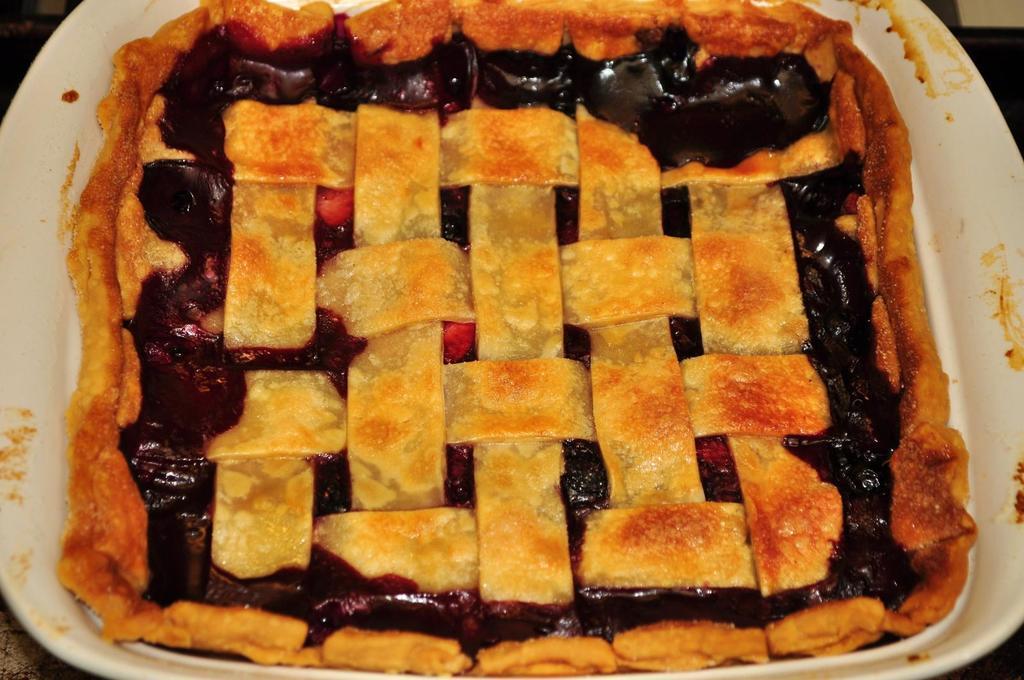How would you summarize this image in a sentence or two? In this picture we can see food in the plate. 